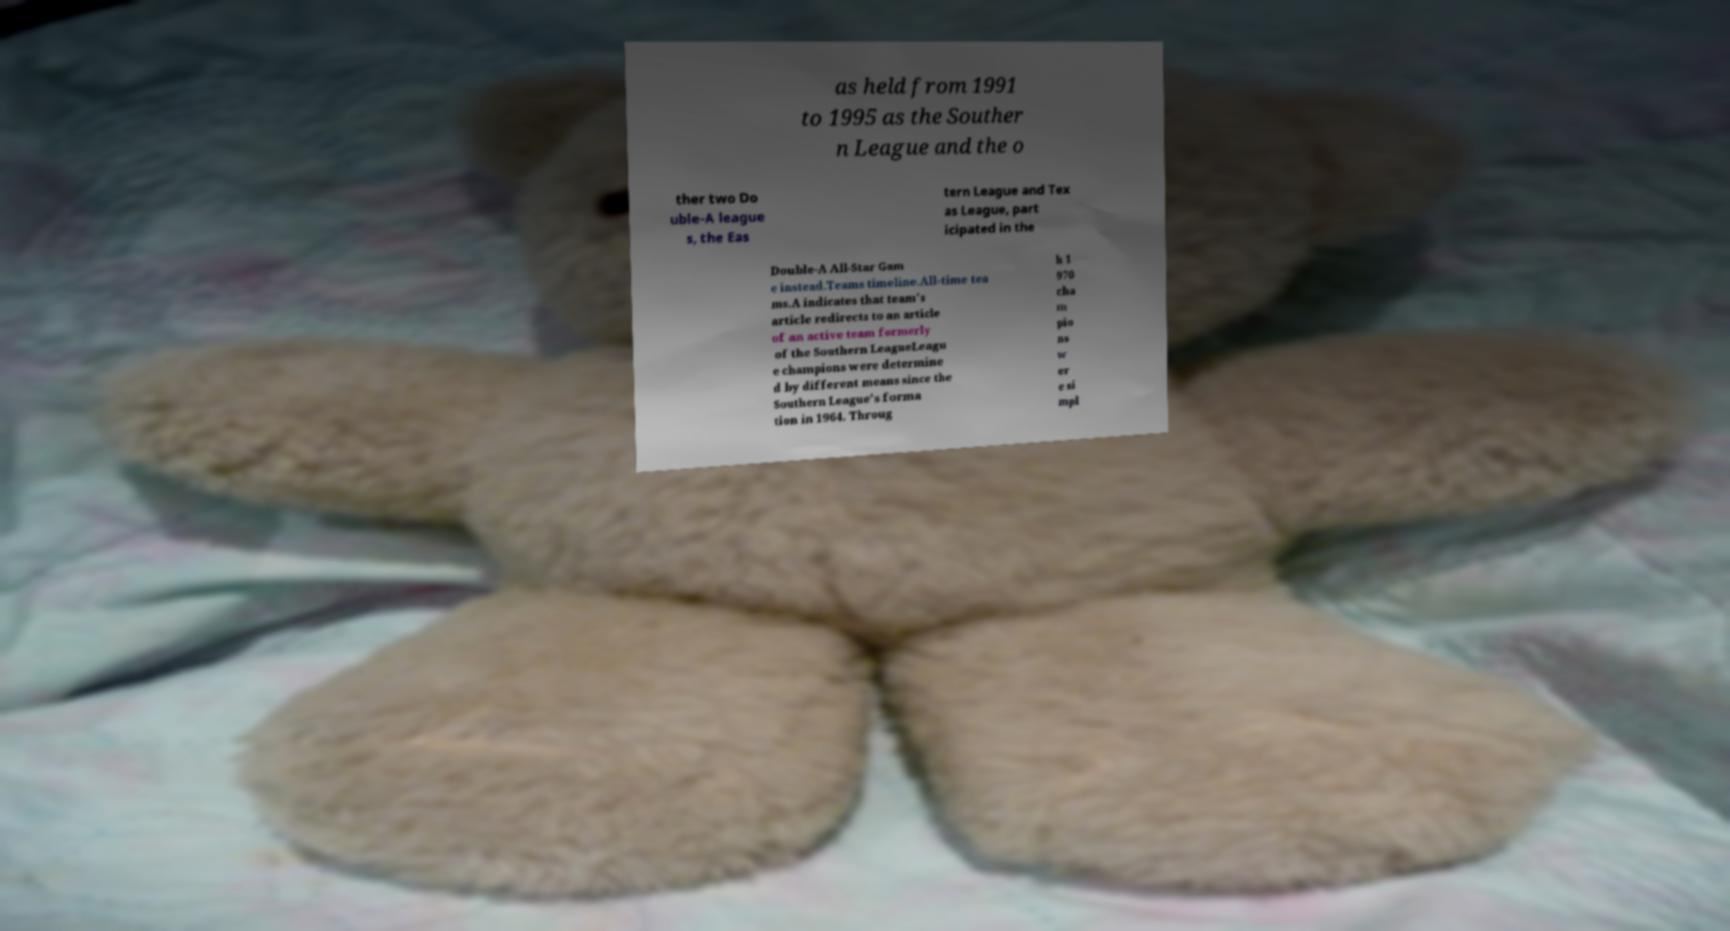What messages or text are displayed in this image? I need them in a readable, typed format. as held from 1991 to 1995 as the Souther n League and the o ther two Do uble-A league s, the Eas tern League and Tex as League, part icipated in the Double-A All-Star Gam e instead.Teams timeline.All-time tea ms.A indicates that team's article redirects to an article of an active team formerly of the Southern LeagueLeagu e champions were determine d by different means since the Southern League's forma tion in 1964. Throug h 1 970 cha m pio ns w er e si mpl 